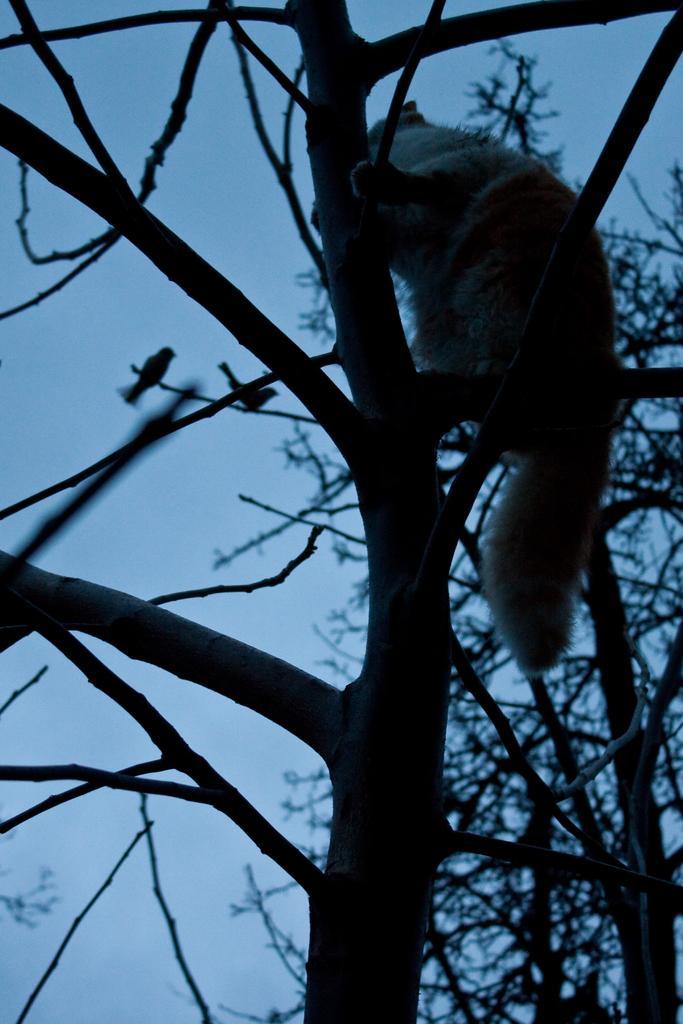Can you describe this image briefly? In this picture we can see there is an animal and two birds are on the branches. Behind the animal there are trees and the sky. 